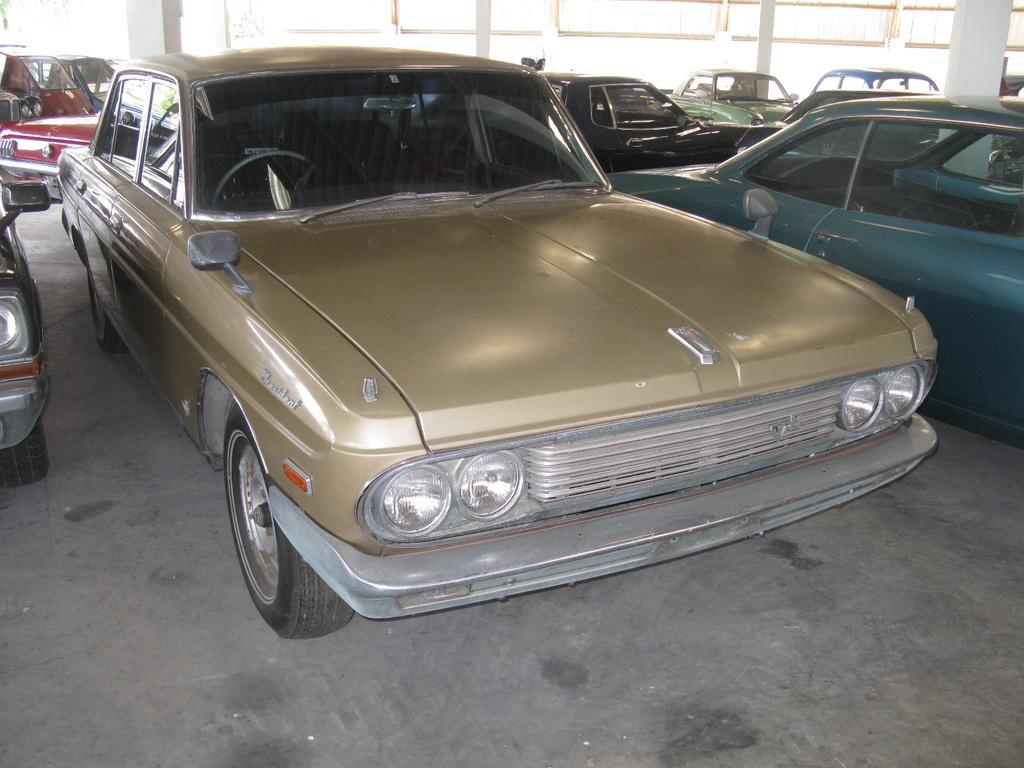What color is the car in the image? The car in the image is gold in color. Are there any other cars in the image? Yes, there are other cars on either side of the gold color car. What can be seen in the background of the image? There are lights and pillars visible in the background of the image. What type of crown is being worn by the committee member in the image? There is no committee member or crown present in the image. What instrument is the drummer playing in the background of the image? There is no drummer or drum present in the image. 